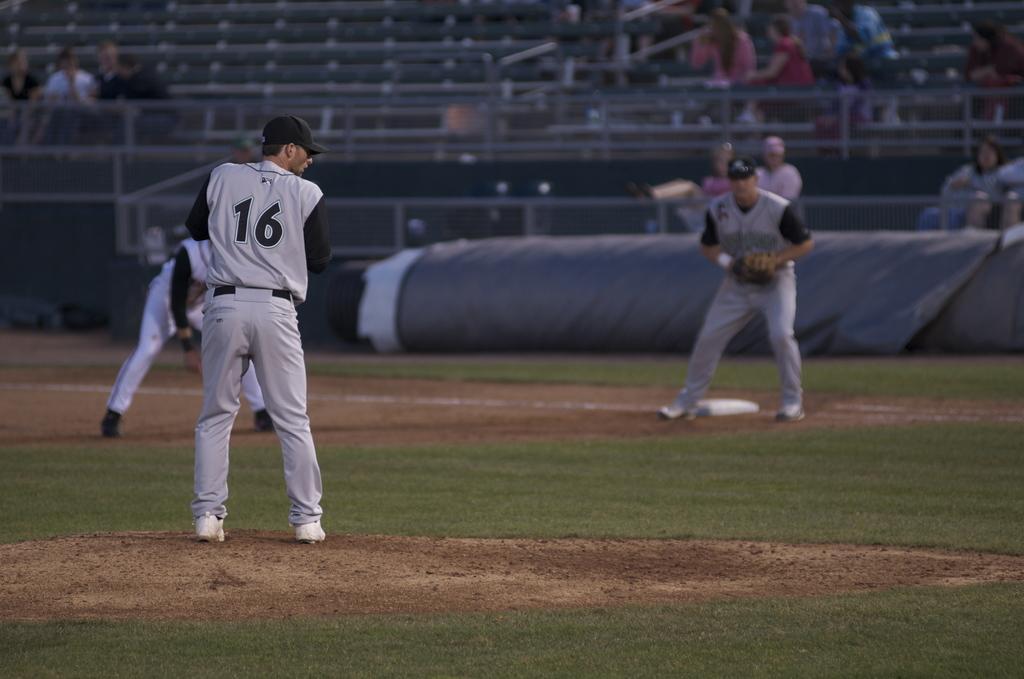In one or two sentences, can you explain what this image depicts? There are three persons playing on the ground. On which, there is grass on the ground. In the background, there are chairs, on some of the cars there are persons. 